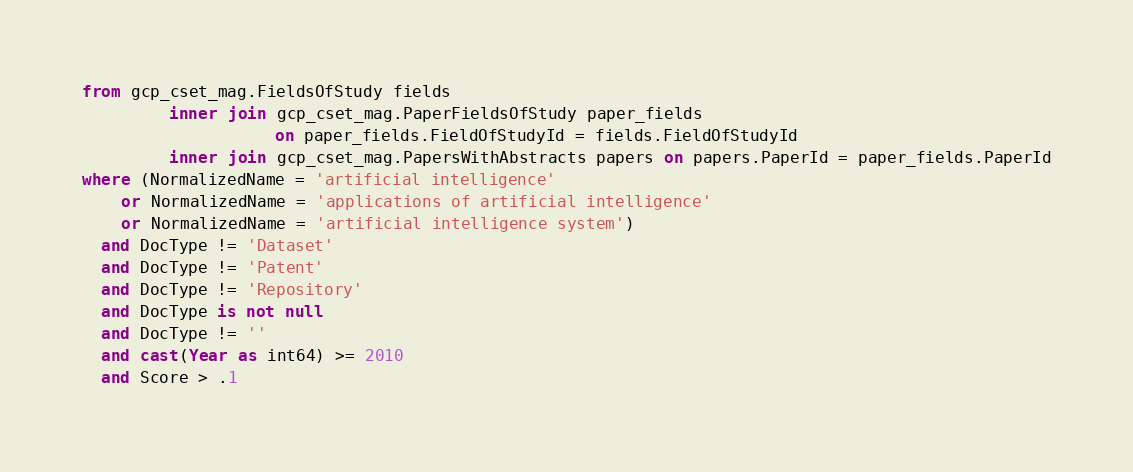<code> <loc_0><loc_0><loc_500><loc_500><_SQL_>from gcp_cset_mag.FieldsOfStudy fields
         inner join gcp_cset_mag.PaperFieldsOfStudy paper_fields
                    on paper_fields.FieldOfStudyId = fields.FieldOfStudyId
         inner join gcp_cset_mag.PapersWithAbstracts papers on papers.PaperId = paper_fields.PaperId
where (NormalizedName = 'artificial intelligence'
    or NormalizedName = 'applications of artificial intelligence'
    or NormalizedName = 'artificial intelligence system')
  and DocType != 'Dataset'
  and DocType != 'Patent'
  and DocType != 'Repository'
  and DocType is not null
  and DocType != ''
  and cast(Year as int64) >= 2010
  and Score > .1
</code> 